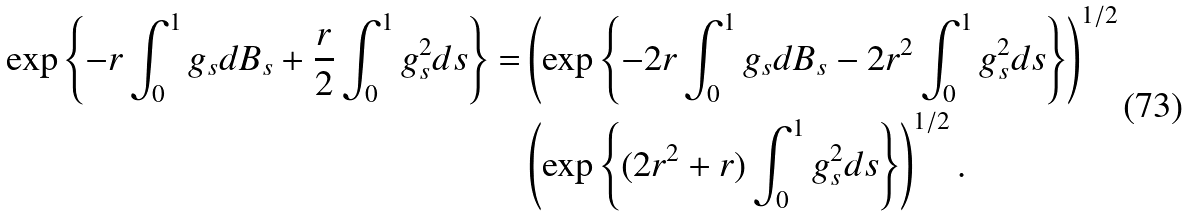Convert formula to latex. <formula><loc_0><loc_0><loc_500><loc_500>\exp \left \{ - r \int _ { 0 } ^ { 1 } g _ { s } d B _ { s } + \frac { r } { 2 } \int _ { 0 } ^ { 1 } g _ { s } ^ { 2 } d s \right \} = & \left ( \exp \left \{ - 2 r \int _ { 0 } ^ { 1 } g _ { s } d B _ { s } - 2 r ^ { 2 } \int _ { 0 } ^ { 1 } g _ { s } ^ { 2 } d s \right \} \right ) ^ { 1 / 2 } \\ & \left ( \exp \left \{ ( 2 r ^ { 2 } + r ) \int _ { 0 } ^ { 1 } g _ { s } ^ { 2 } d s \right \} \right ) ^ { 1 / 2 } .</formula> 